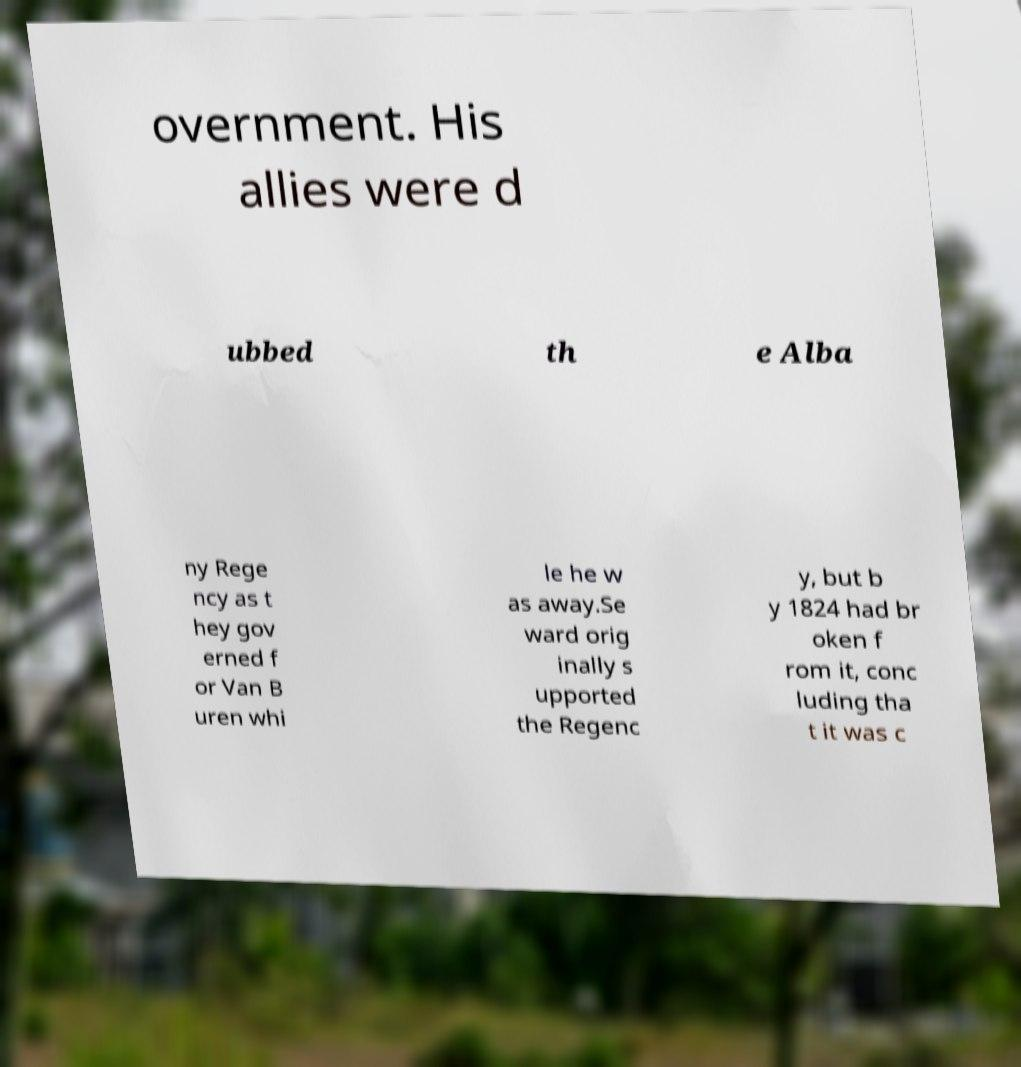Can you read and provide the text displayed in the image?This photo seems to have some interesting text. Can you extract and type it out for me? overnment. His allies were d ubbed th e Alba ny Rege ncy as t hey gov erned f or Van B uren whi le he w as away.Se ward orig inally s upported the Regenc y, but b y 1824 had br oken f rom it, conc luding tha t it was c 